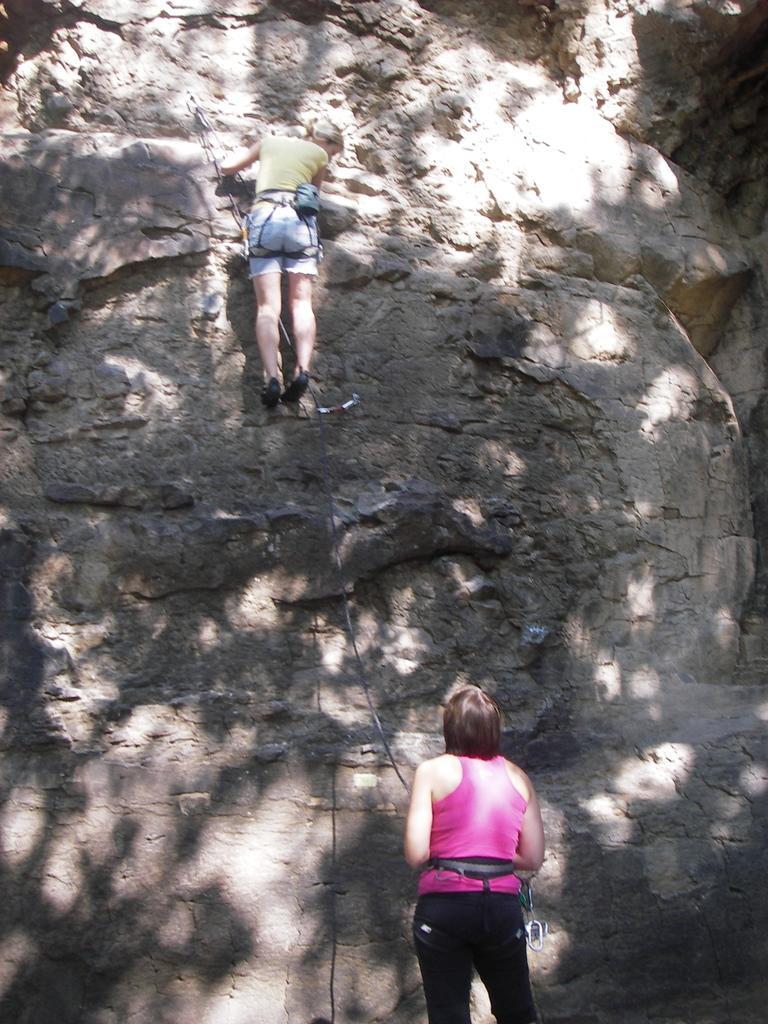Describe this image in one or two sentences. In this image we can see a person climbing a mountain. At the bottom we can see another person. 